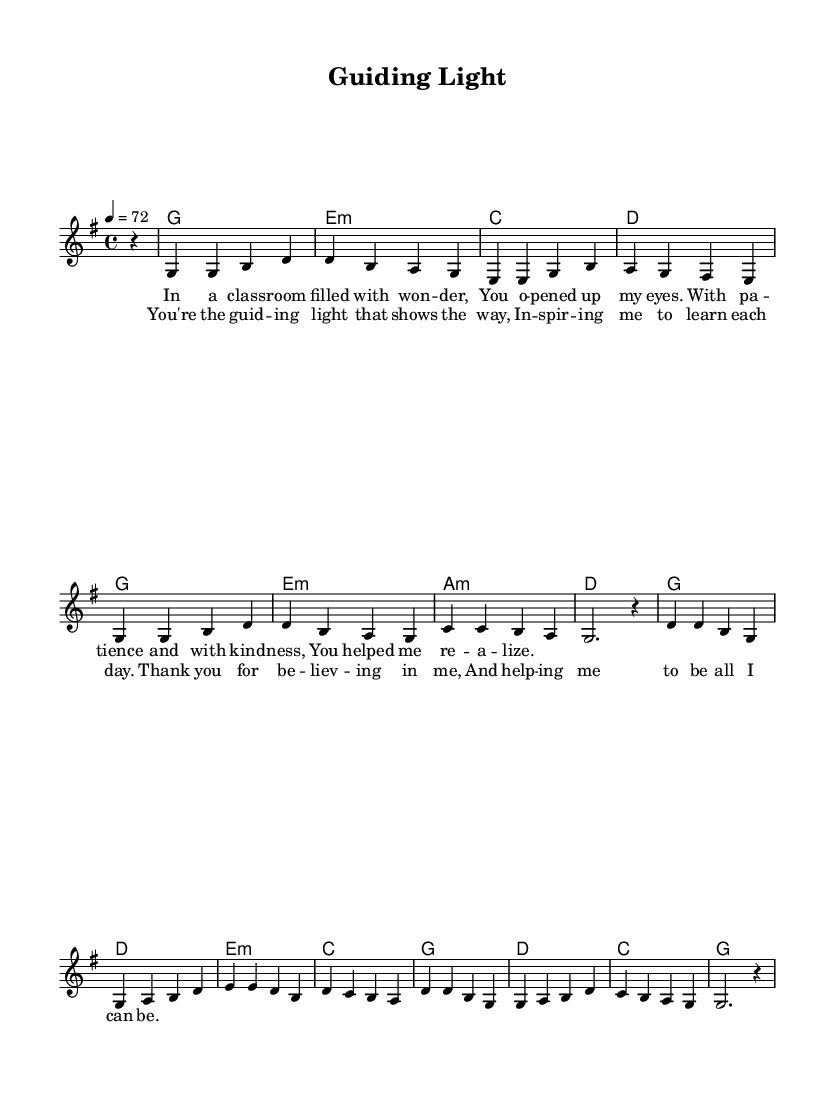What is the key signature of this music? The key signature indicated in the music sheet is G major, which has one sharp (F#). This can be identified by looking at the key signature marking at the beginning of the staff.
Answer: G major What is the time signature of this music? The time signature shown at the beginning of the piece is 4/4. This can be determined by identifying the numbers located just after the key signature, where the top number indicates four beats in a measure, and the bottom number indicates that the quarter note receives one beat.
Answer: 4/4 What is the tempo marking for this piece? The tempo marking specified in the music sheet is 4 = 72. This indicates that there are 72 quarter note beats per minute, which can usually be found at the beginning of the score next to the tempo.
Answer: 72 How many measures are in the chorus? The chorus consists of four measures. By counting the vertical lines separating the music sections in the chorus lyrics, you can determine how many measures are present.
Answer: Four What type of chord is used in the first measure? The first measure features a G major chord, which can be identified by the chord symbols indicated above the staff (g1). The G major chord consists of the notes G, B, and D, which pertain to the key of G major.
Answer: G major Why is this song categorized as a country ballad? This song is categorized as a country ballad because it features common elements of the country genre, such as storytelling lyrics centered around personal experiences and emotional themes, with a slow tempo that evokes reflective sentiments. The lyrics express gratitude and inspiration, which resonate with typical country ballad themes.
Answer: Country ballad 